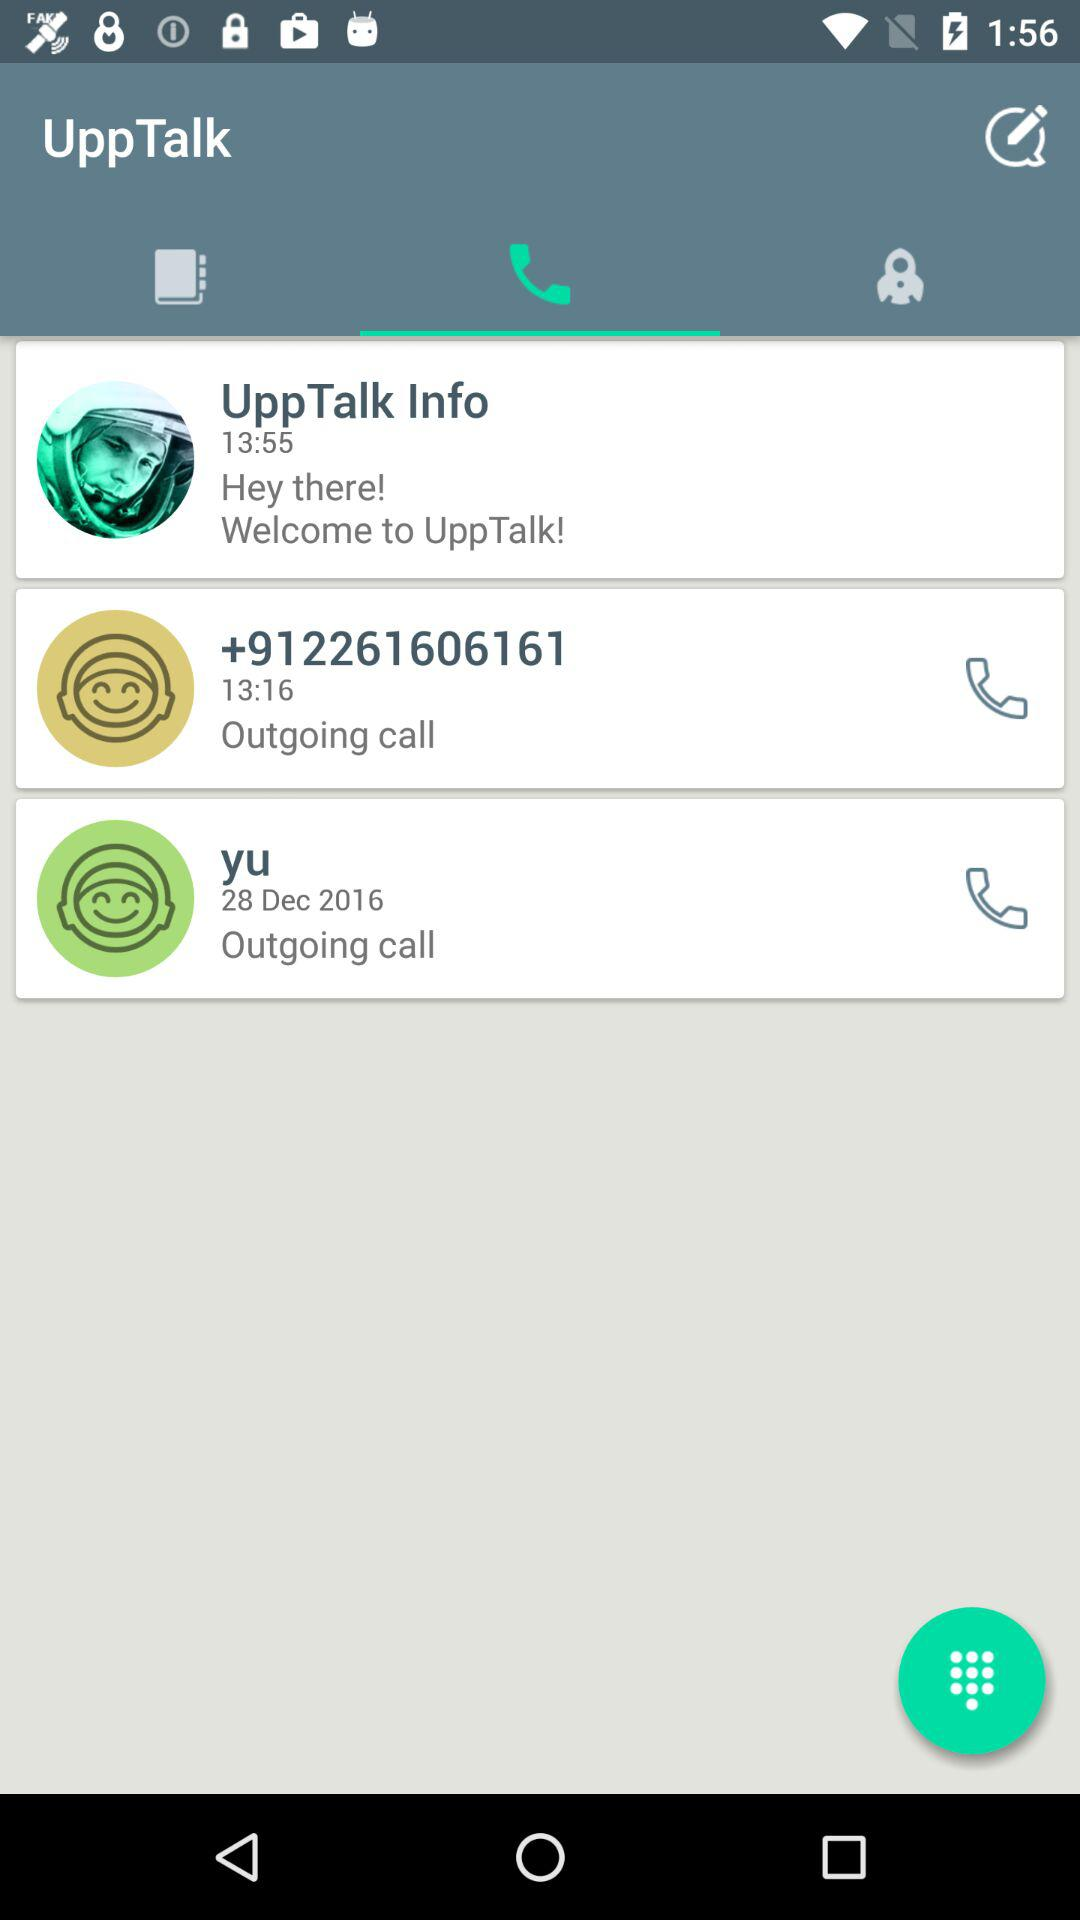What is the date of the outgoing call from "yu"? The date of the outgoing call from "yu" is December 28, 2016. 